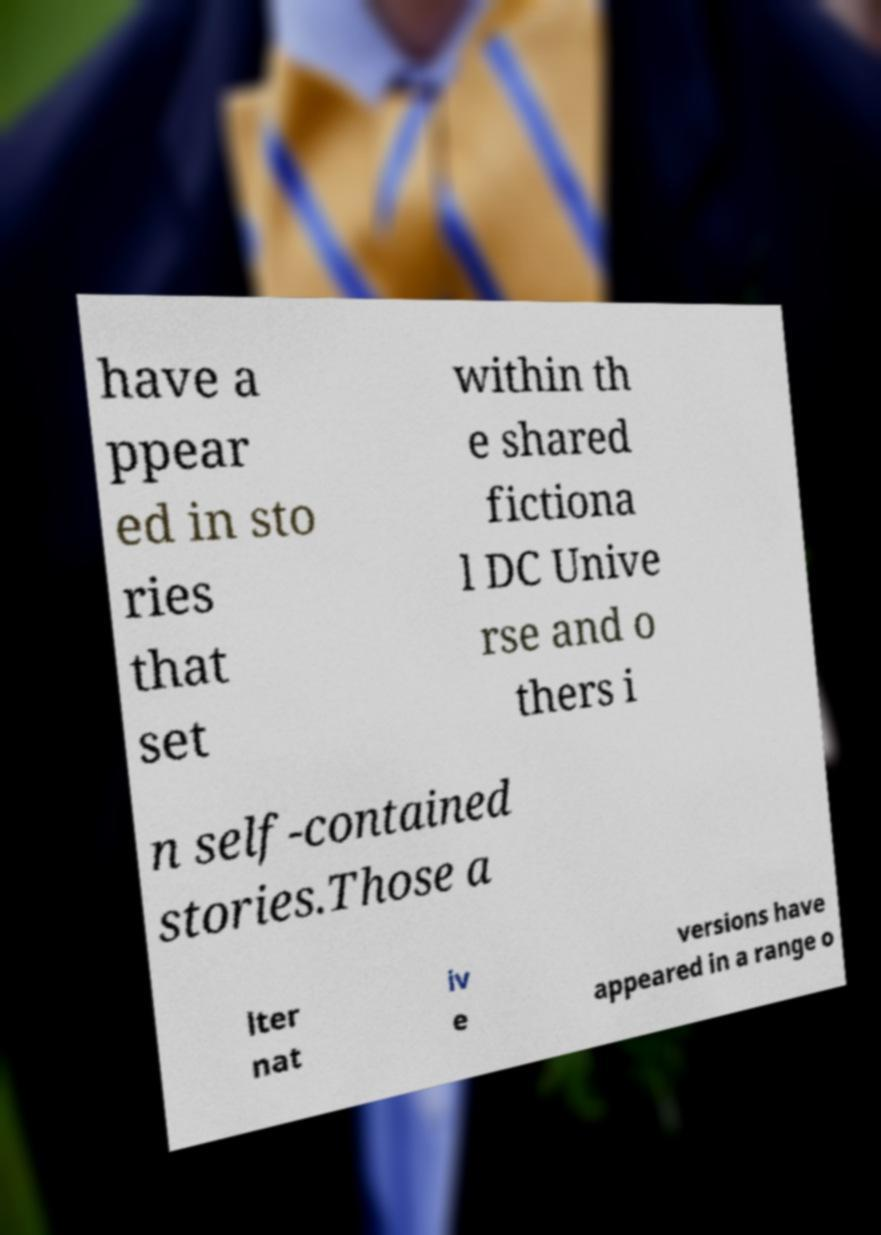There's text embedded in this image that I need extracted. Can you transcribe it verbatim? have a ppear ed in sto ries that set within th e shared fictiona l DC Unive rse and o thers i n self-contained stories.Those a lter nat iv e versions have appeared in a range o 